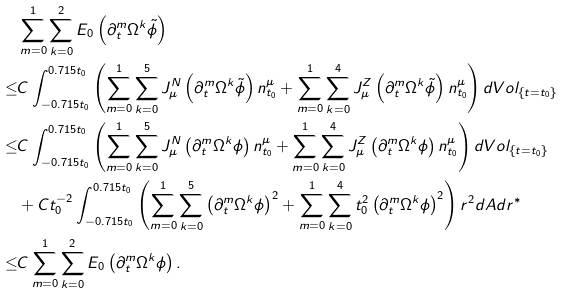Convert formula to latex. <formula><loc_0><loc_0><loc_500><loc_500>& \sum _ { m = 0 } ^ { 1 } \sum _ { k = 0 } ^ { 2 } E _ { 0 } \left ( \partial _ { t } ^ { m } \Omega ^ { k } \tilde { \phi } \right ) \\ \leq & C \int _ { - 0 . 7 1 5 t _ { 0 } } ^ { 0 . 7 1 5 t _ { 0 } } \left ( \sum _ { m = 0 } ^ { 1 } \sum _ { k = 0 } ^ { 5 } J ^ { N } _ { \mu } \left ( \partial _ { t } ^ { m } \Omega ^ { k } \tilde { \phi } \right ) n _ { t _ { 0 } } ^ { \mu } + \sum _ { m = 0 } ^ { 1 } \sum _ { k = 0 } ^ { 4 } J ^ { Z } _ { \mu } \left ( \partial _ { t } ^ { m } \Omega ^ { k } \tilde { \phi } \right ) n _ { t _ { 0 } } ^ { \mu } \right ) d V o l _ { \{ t = t _ { 0 } \} } \\ \leq & C \int _ { - 0 . 7 1 5 t _ { 0 } } ^ { 0 . 7 1 5 t _ { 0 } } \left ( \sum _ { m = 0 } ^ { 1 } \sum _ { k = 0 } ^ { 5 } J ^ { N } _ { \mu } \left ( \partial _ { t } ^ { m } \Omega ^ { k } \phi \right ) n _ { t _ { 0 } } ^ { \mu } + \sum _ { m = 0 } ^ { 1 } \sum _ { k = 0 } ^ { 4 } J ^ { Z } _ { \mu } \left ( \partial _ { t } ^ { m } \Omega ^ { k } \phi \right ) n _ { t _ { 0 } } ^ { \mu } \right ) d V o l _ { \{ t = t _ { 0 } \} } \\ & + C t _ { 0 } ^ { - 2 } \int _ { - 0 . 7 1 5 t _ { 0 } } ^ { 0 . 7 1 5 t _ { 0 } } \left ( \sum _ { m = 0 } ^ { 1 } \sum _ { k = 0 } ^ { 5 } \left ( \partial _ { t } ^ { m } \Omega ^ { k } \phi \right ) ^ { 2 } + \sum _ { m = 0 } ^ { 1 } \sum _ { k = 0 } ^ { 4 } t _ { 0 } ^ { 2 } \left ( \partial _ { t } ^ { m } \Omega ^ { k } \phi \right ) ^ { 2 } \right ) r ^ { 2 } d A d r ^ { * } \\ \leq & C \sum _ { m = 0 } ^ { 1 } \sum _ { k = 0 } ^ { 2 } E _ { 0 } \left ( \partial _ { t } ^ { m } \Omega ^ { k } \phi \right ) .</formula> 